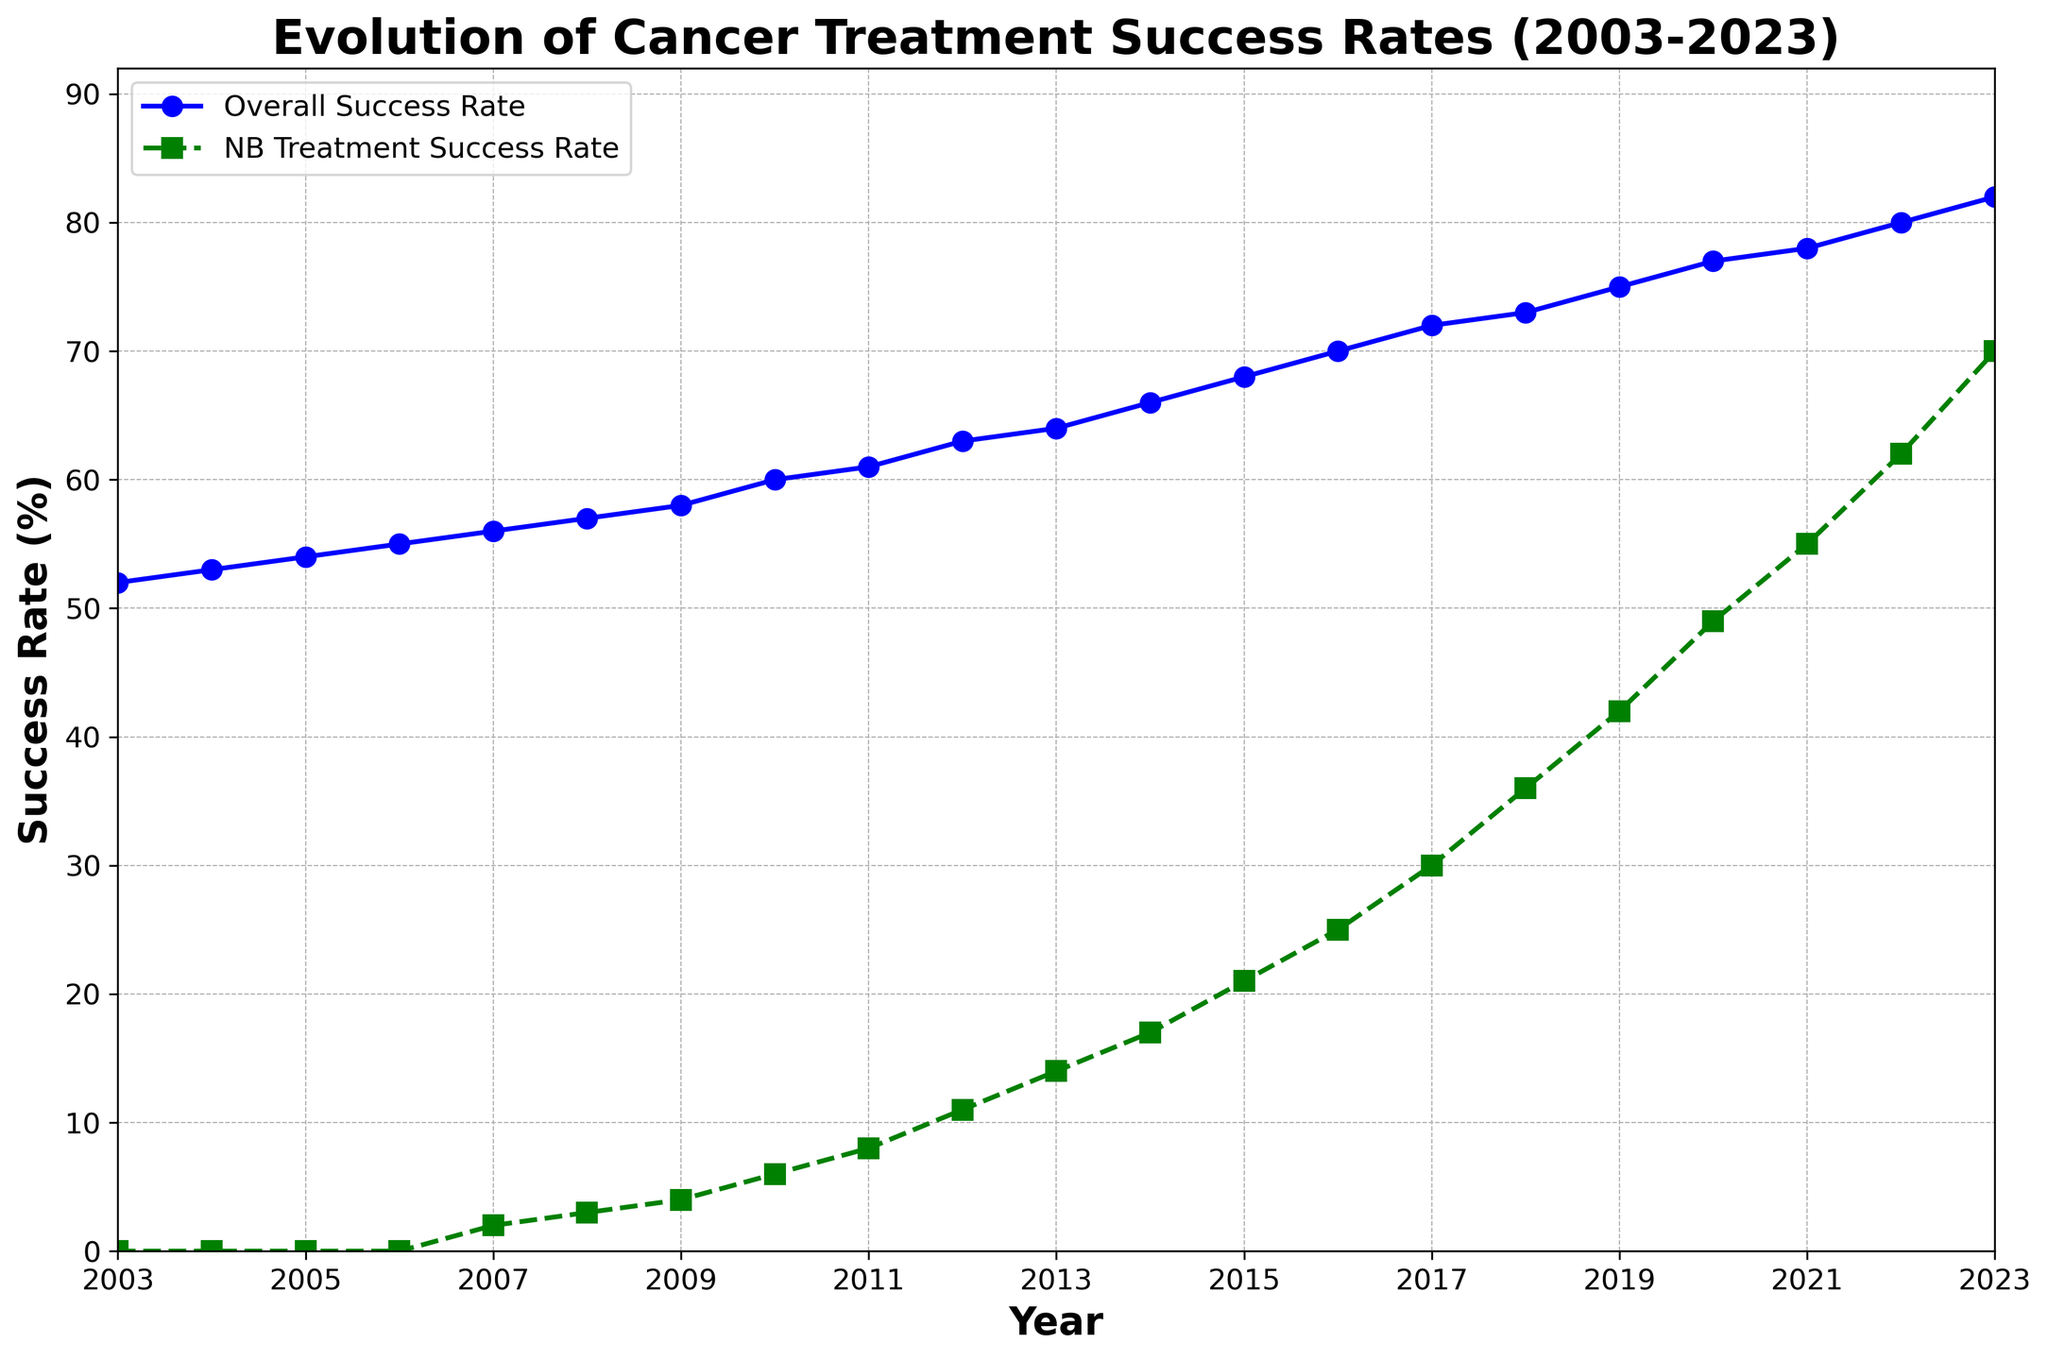what is the Overall Success Rate in 2010? We need to refer to the data line. In 2010, the Overall Success Rate is represented by the blue line at the data point corresponding to 2010.
Answer: 60 what is the difference in success rates between Overall and NB Treatment in 2023? Look at the success rates for both therapies in the year 2023. Overall Success Rate is 82 and NB Treatment Success Rate is 70. The difference is 82 - 70.
Answer: 12 Between which two consecutive years did the NB Treatment Success Rate increase the most? Compare the difference in NB Treatment Success Rates between all consecutive years. The largest increase occurs when the difference is maximum. The increase is largest between 2016 and 2017, from 25 to 30.
Answer: 2016 and 2017 what is the average Overall Success Rate from 2003 to 2023? Sum up the values of the Overall Success Rate from 2003 to 2023 and divide by the number of years (21 years). Sum = 52+53+54+55+56+57+58+60+61+63+64+66+68+70+72+73+75+77+78+80+82 = 1375. Average = 1375/21.
Answer: 65.48 How does the trend of the NB Treatment Success Rate from 2007 to 2023 compare to the Overall Success Rate? From 2007 to 2023, visually note the steep ascent in the green NB Treatment line compared to the more gradual blue Overall Success Rate line. NB Treatment starts slower but shows a sharper rise.
Answer: Steeper rise In what year did the NB Treatment Success Rate first reach 50%? Scan the NB Treatment Success Rate line (green) from left to right until it hits or exceeds 50%. It reaches 50% in the year 2020.
Answer: 2020 How much has the Overall Success Rate improved from 2003 to 2023? Subtract the Overall Success Rate in 2003 from that in 2023. In 2003, it is 52, and in 2023, it is 82. Therefore, 82 - 52.
Answer: 30 which year shows the highest gap between Overall and NB Treatment Success Rates? Calculate the differences between Overall and NB Treatment Success Rates for each year and find the maximum difference. The highest gap is in 2007, where the difference is 54 (Overall) - 2 (NB Treatment) = 54.
Answer: 2007 